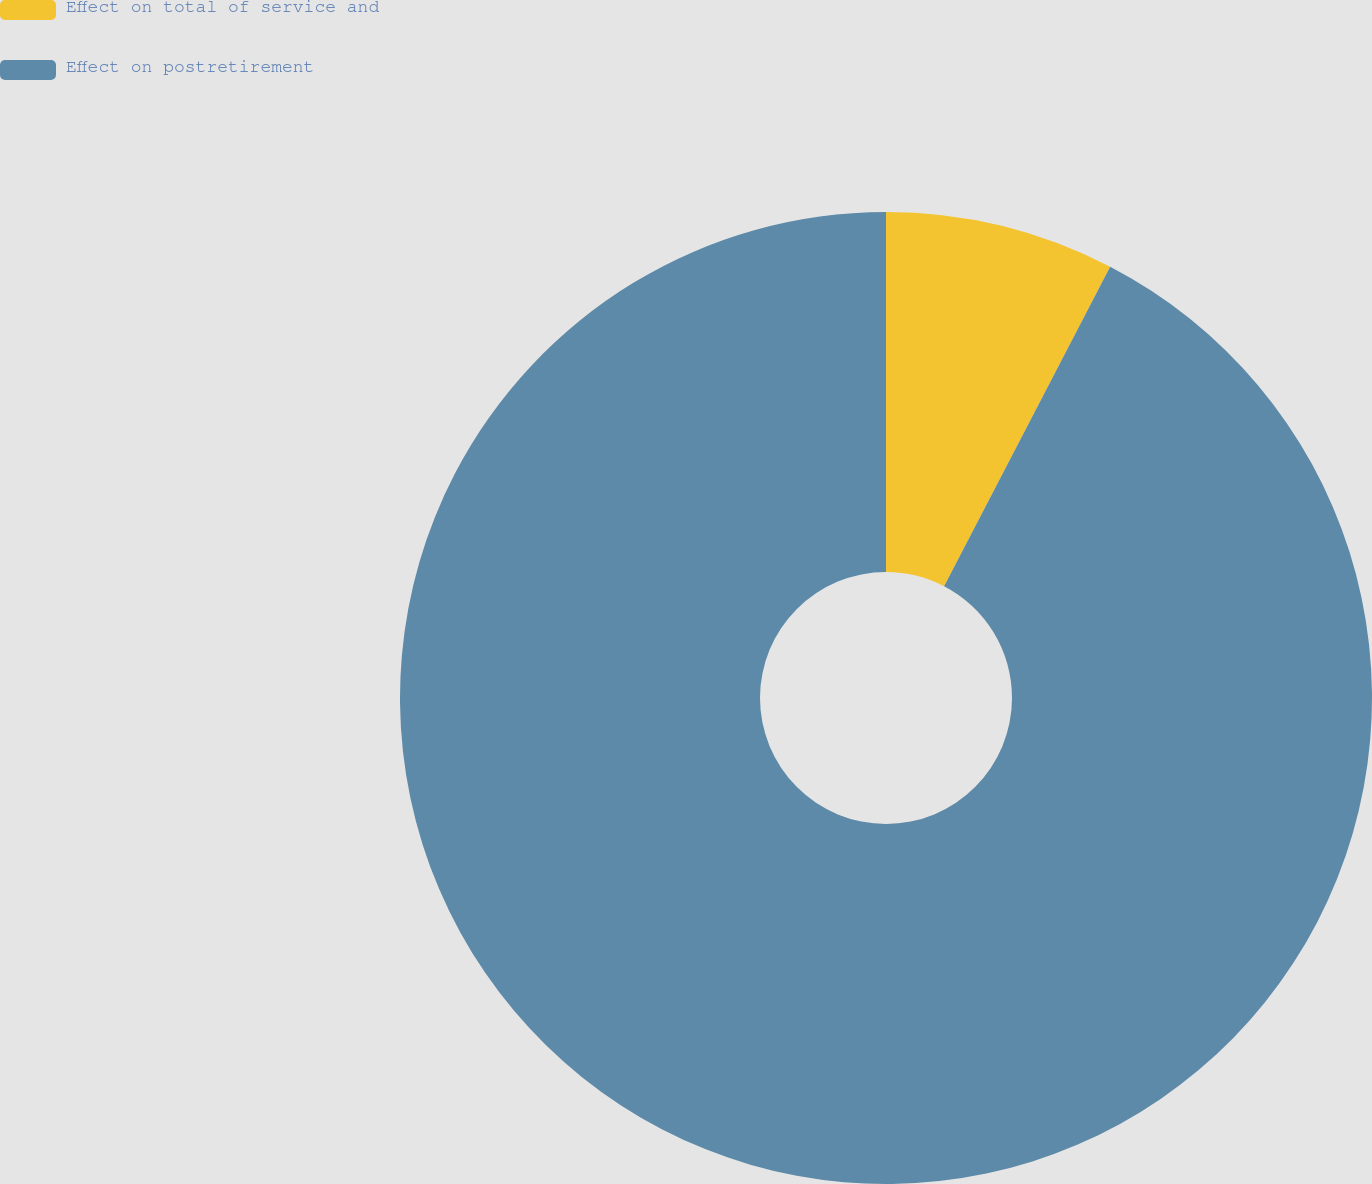Convert chart. <chart><loc_0><loc_0><loc_500><loc_500><pie_chart><fcel>Effect on total of service and<fcel>Effect on postretirement<nl><fcel>7.63%<fcel>92.37%<nl></chart> 